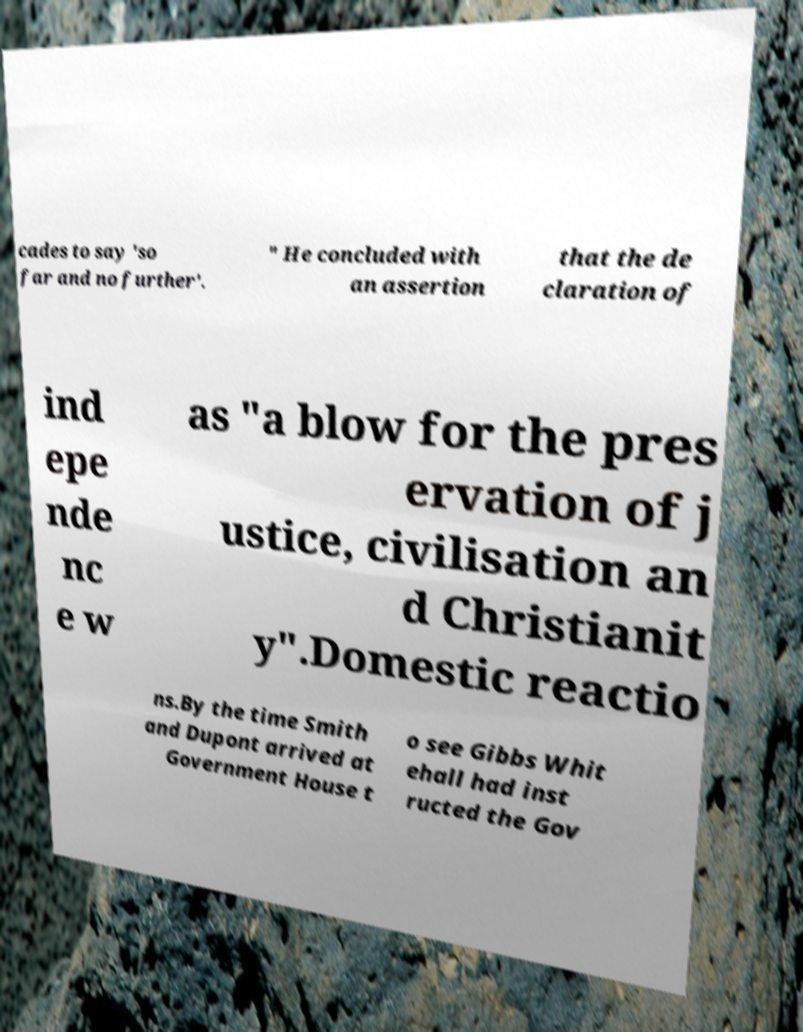Can you read and provide the text displayed in the image?This photo seems to have some interesting text. Can you extract and type it out for me? cades to say 'so far and no further'. " He concluded with an assertion that the de claration of ind epe nde nc e w as "a blow for the pres ervation of j ustice, civilisation an d Christianit y".Domestic reactio ns.By the time Smith and Dupont arrived at Government House t o see Gibbs Whit ehall had inst ructed the Gov 